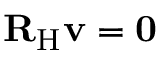<formula> <loc_0><loc_0><loc_500><loc_500>{ R } _ { H } { v } = 0</formula> 